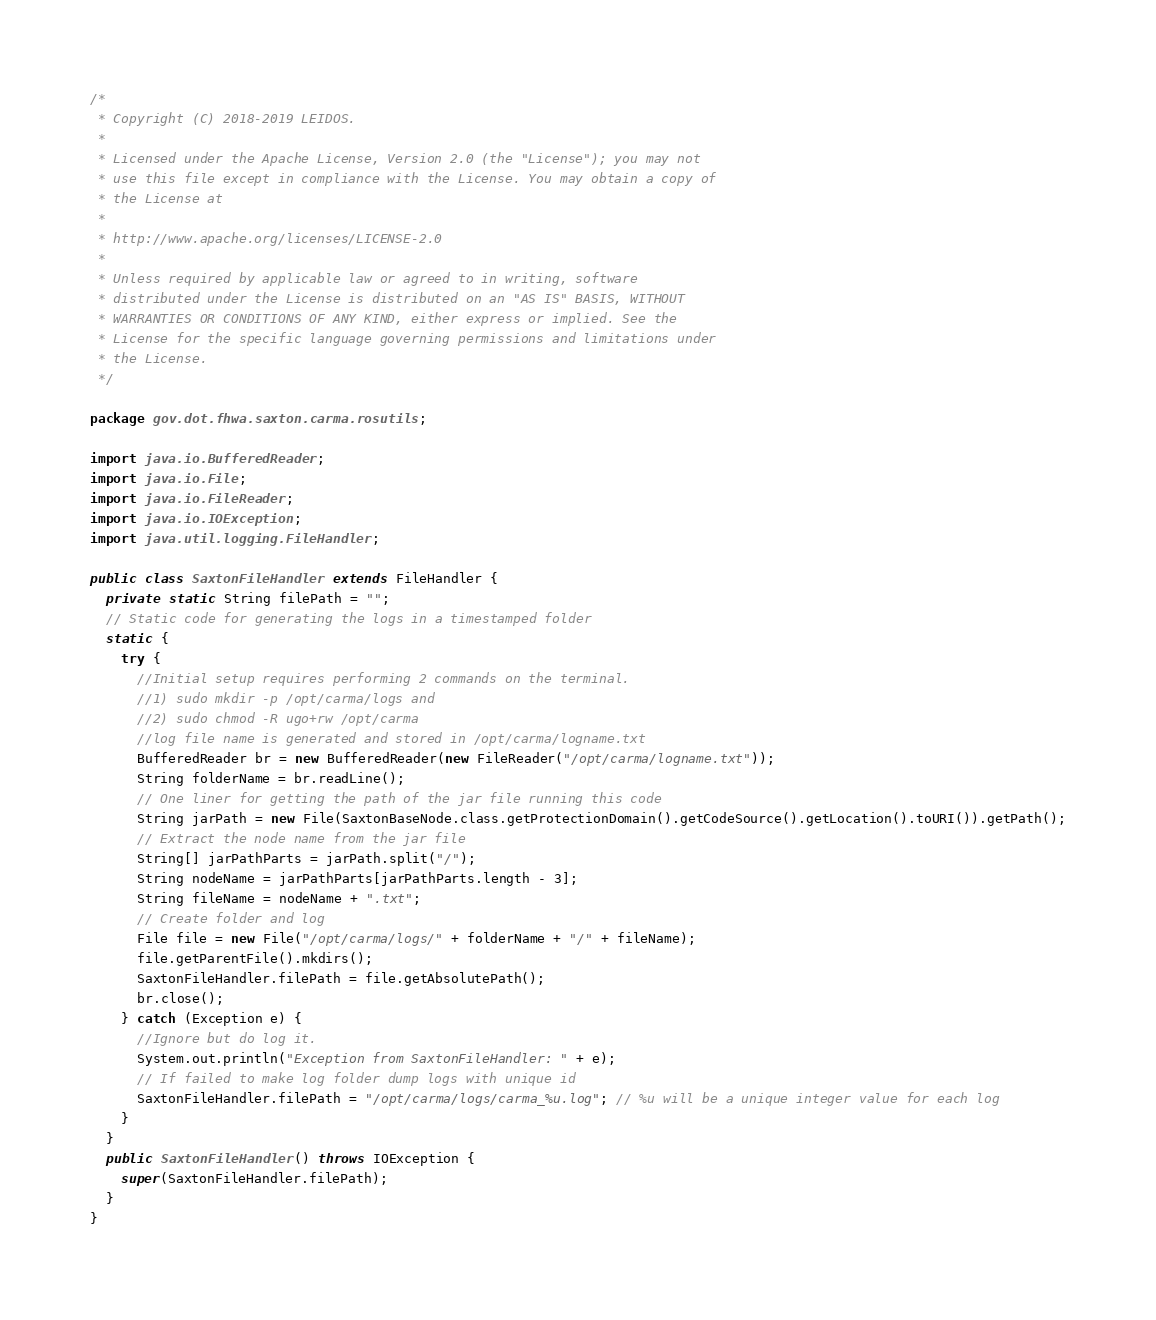Convert code to text. <code><loc_0><loc_0><loc_500><loc_500><_Java_>/*
 * Copyright (C) 2018-2019 LEIDOS.
 *
 * Licensed under the Apache License, Version 2.0 (the "License"); you may not
 * use this file except in compliance with the License. You may obtain a copy of
 * the License at
 *
 * http://www.apache.org/licenses/LICENSE-2.0
 *
 * Unless required by applicable law or agreed to in writing, software
 * distributed under the License is distributed on an "AS IS" BASIS, WITHOUT
 * WARRANTIES OR CONDITIONS OF ANY KIND, either express or implied. See the
 * License for the specific language governing permissions and limitations under
 * the License.
 */

package gov.dot.fhwa.saxton.carma.rosutils;

import java.io.BufferedReader;
import java.io.File;
import java.io.FileReader;
import java.io.IOException;
import java.util.logging.FileHandler;

public class SaxtonFileHandler extends FileHandler {
  private static String filePath = "";
  // Static code for generating the logs in a timestamped folder
  static {
    try {
      //Initial setup requires performing 2 commands on the terminal.
      //1) sudo mkdir -p /opt/carma/logs and
      //2) sudo chmod -R ugo+rw /opt/carma
      //log file name is generated and stored in /opt/carma/logname.txt
      BufferedReader br = new BufferedReader(new FileReader("/opt/carma/logname.txt")); 
      String folderName = br.readLine();
      // One liner for getting the path of the jar file running this code
      String jarPath = new File(SaxtonBaseNode.class.getProtectionDomain().getCodeSource().getLocation().toURI()).getPath();
      // Extract the node name from the jar file
      String[] jarPathParts = jarPath.split("/");
      String nodeName = jarPathParts[jarPathParts.length - 3];
      String fileName = nodeName + ".txt";
      // Create folder and log
      File file = new File("/opt/carma/logs/" + folderName + "/" + fileName); 
      file.getParentFile().mkdirs();
      SaxtonFileHandler.filePath = file.getAbsolutePath();
      br.close();
    } catch (Exception e) {
      //Ignore but do log it.
      System.out.println("Exception from SaxtonFileHandler: " + e);
      // If failed to make log folder dump logs with unique id
      SaxtonFileHandler.filePath = "/opt/carma/logs/carma_%u.log"; // %u will be a unique integer value for each log
    }
  }
  public SaxtonFileHandler() throws IOException {
    super(SaxtonFileHandler.filePath);
  }
}</code> 